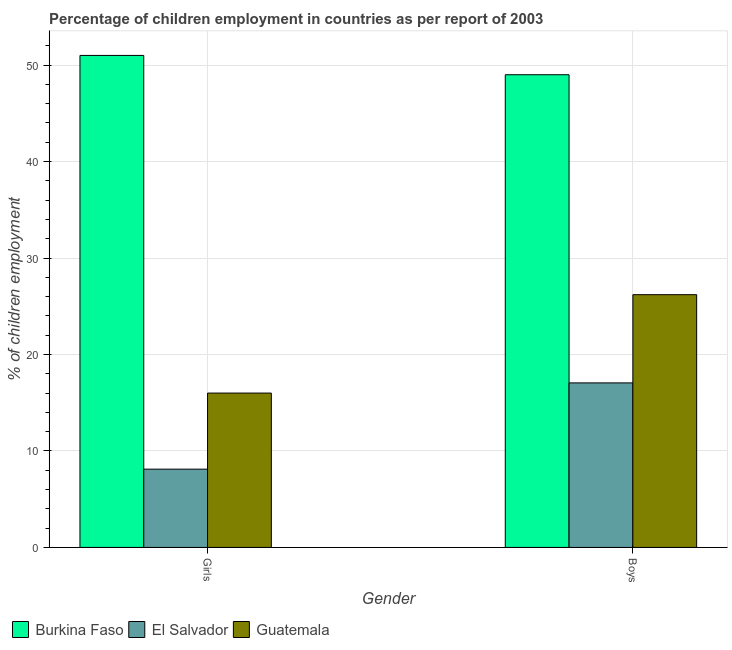How many different coloured bars are there?
Offer a very short reply. 3. How many groups of bars are there?
Provide a succinct answer. 2. Are the number of bars per tick equal to the number of legend labels?
Offer a very short reply. Yes. How many bars are there on the 1st tick from the left?
Offer a very short reply. 3. What is the label of the 2nd group of bars from the left?
Give a very brief answer. Boys. What is the percentage of employed girls in El Salvador?
Provide a succinct answer. 8.11. Across all countries, what is the minimum percentage of employed girls?
Ensure brevity in your answer.  8.11. In which country was the percentage of employed boys maximum?
Your response must be concise. Burkina Faso. In which country was the percentage of employed boys minimum?
Your response must be concise. El Salvador. What is the total percentage of employed girls in the graph?
Give a very brief answer. 75.11. What is the difference between the percentage of employed girls in El Salvador and that in Guatemala?
Make the answer very short. -7.89. What is the difference between the percentage of employed girls in Burkina Faso and the percentage of employed boys in El Salvador?
Ensure brevity in your answer.  33.94. What is the average percentage of employed girls per country?
Keep it short and to the point. 25.04. In how many countries, is the percentage of employed girls greater than 24 %?
Make the answer very short. 1. What is the ratio of the percentage of employed girls in El Salvador to that in Burkina Faso?
Offer a terse response. 0.16. What does the 1st bar from the left in Girls represents?
Keep it short and to the point. Burkina Faso. What does the 2nd bar from the right in Girls represents?
Keep it short and to the point. El Salvador. How many bars are there?
Provide a succinct answer. 6. How many countries are there in the graph?
Provide a short and direct response. 3. Does the graph contain any zero values?
Provide a short and direct response. No. Does the graph contain grids?
Your answer should be compact. Yes. What is the title of the graph?
Offer a very short reply. Percentage of children employment in countries as per report of 2003. Does "Central Europe" appear as one of the legend labels in the graph?
Offer a very short reply. No. What is the label or title of the X-axis?
Your response must be concise. Gender. What is the label or title of the Y-axis?
Offer a terse response. % of children employment. What is the % of children employment of Burkina Faso in Girls?
Your response must be concise. 51. What is the % of children employment of El Salvador in Girls?
Your response must be concise. 8.11. What is the % of children employment in Guatemala in Girls?
Keep it short and to the point. 16. What is the % of children employment of Burkina Faso in Boys?
Offer a very short reply. 49. What is the % of children employment of El Salvador in Boys?
Offer a terse response. 17.06. What is the % of children employment of Guatemala in Boys?
Ensure brevity in your answer.  26.2. Across all Gender, what is the maximum % of children employment in Burkina Faso?
Your answer should be compact. 51. Across all Gender, what is the maximum % of children employment of El Salvador?
Your answer should be compact. 17.06. Across all Gender, what is the maximum % of children employment of Guatemala?
Offer a terse response. 26.2. Across all Gender, what is the minimum % of children employment of Burkina Faso?
Your answer should be very brief. 49. Across all Gender, what is the minimum % of children employment of El Salvador?
Keep it short and to the point. 8.11. Across all Gender, what is the minimum % of children employment in Guatemala?
Your response must be concise. 16. What is the total % of children employment in Burkina Faso in the graph?
Make the answer very short. 100. What is the total % of children employment of El Salvador in the graph?
Ensure brevity in your answer.  25.17. What is the total % of children employment of Guatemala in the graph?
Ensure brevity in your answer.  42.2. What is the difference between the % of children employment in Burkina Faso in Girls and that in Boys?
Offer a terse response. 2. What is the difference between the % of children employment of El Salvador in Girls and that in Boys?
Offer a very short reply. -8.94. What is the difference between the % of children employment in Guatemala in Girls and that in Boys?
Provide a succinct answer. -10.2. What is the difference between the % of children employment of Burkina Faso in Girls and the % of children employment of El Salvador in Boys?
Provide a succinct answer. 33.94. What is the difference between the % of children employment of Burkina Faso in Girls and the % of children employment of Guatemala in Boys?
Ensure brevity in your answer.  24.8. What is the difference between the % of children employment of El Salvador in Girls and the % of children employment of Guatemala in Boys?
Your answer should be compact. -18.09. What is the average % of children employment in Burkina Faso per Gender?
Offer a terse response. 50. What is the average % of children employment of El Salvador per Gender?
Offer a very short reply. 12.58. What is the average % of children employment of Guatemala per Gender?
Offer a terse response. 21.1. What is the difference between the % of children employment of Burkina Faso and % of children employment of El Salvador in Girls?
Provide a succinct answer. 42.89. What is the difference between the % of children employment of Burkina Faso and % of children employment of Guatemala in Girls?
Give a very brief answer. 35. What is the difference between the % of children employment of El Salvador and % of children employment of Guatemala in Girls?
Your answer should be compact. -7.89. What is the difference between the % of children employment in Burkina Faso and % of children employment in El Salvador in Boys?
Provide a short and direct response. 31.94. What is the difference between the % of children employment of Burkina Faso and % of children employment of Guatemala in Boys?
Give a very brief answer. 22.8. What is the difference between the % of children employment of El Salvador and % of children employment of Guatemala in Boys?
Offer a very short reply. -9.14. What is the ratio of the % of children employment of Burkina Faso in Girls to that in Boys?
Your answer should be very brief. 1.04. What is the ratio of the % of children employment of El Salvador in Girls to that in Boys?
Make the answer very short. 0.48. What is the ratio of the % of children employment of Guatemala in Girls to that in Boys?
Give a very brief answer. 0.61. What is the difference between the highest and the second highest % of children employment in Burkina Faso?
Offer a very short reply. 2. What is the difference between the highest and the second highest % of children employment of El Salvador?
Your answer should be compact. 8.94. What is the difference between the highest and the second highest % of children employment of Guatemala?
Provide a succinct answer. 10.2. What is the difference between the highest and the lowest % of children employment of Burkina Faso?
Provide a succinct answer. 2. What is the difference between the highest and the lowest % of children employment of El Salvador?
Provide a short and direct response. 8.94. What is the difference between the highest and the lowest % of children employment in Guatemala?
Provide a short and direct response. 10.2. 